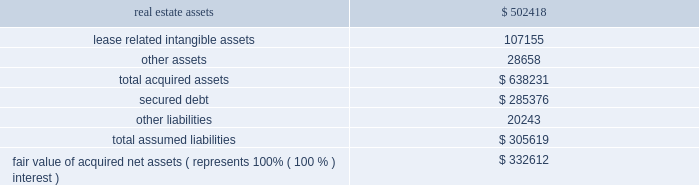57 annual report 2010 duke realty corporation | | level 2 inputs are inputs other than quoted prices included in level 1 that are observable for the asset or liability , either directly or indirectly .
Level 2 inputs may include quoted prices for similar assets and liabilities in active markets , as well as inputs that are observable for the asset or liability ( other than quoted prices ) , such as interest rates and yield curves that are observable at commonly quoted intervals .
Level 3 inputs are unobservable inputs for the asset or liability , which are typically based on an entity 2019s own assumptions , as there is little , if any , related market activity .
In instances where the determination of the fair value measurement is based on inputs from different levels of the fair value hierarchy , the level in the fair value hierarchy within which the entire fair value measurement falls is based on the lowest level input that is significant to the fair value measurement in its entirety .
Our assessment of the significance of a particular input to the fair value measurement in its entirety requires judgment and considers factors specific to the asset or liability .
Use of estimates the preparation of the financial statements requires management to make a number of estimates and assumptions that affect the reported amount of assets and liabilities and the disclosure of contingent assets and liabilities at the date of the financial statements and the reported amounts of revenues and expenses during the period .
The most significant estimates , as discussed within our summary of significant accounting policies , pertain to the critical assumptions utilized in testing real estate assets for impairment as well as in estimating the fair value of real estate assets when an impairment event has taken place .
Actual results could differ from those estimates .
( 3 ) significant acquisitions and dispositions 2010 acquisition of remaining interest in dugan realty , l.l.c .
On july 1 , 2010 , we acquired our joint venture partner 2019s 50% ( 50 % ) interest in dugan realty , l.l.c .
( 201cdugan 201d ) , a real estate joint venture that we had previously accounted for using the equity method , for a payment of $ 166.7 million .
Dugan held $ 28.1 million of cash at the time of acquisition , which resulted in a net cash outlay of $ 138.6 million .
As the result of this transaction we obtained 100% ( 100 % ) of dugan 2019s membership interests .
At the date of acquisition , dugan owned 106 industrial buildings totaling 20.8 million square feet and 63 net acres of undeveloped land located in midwest and southeast markets .
Dugan had a secured loan with a face value of $ 195.4 million due in october 2010 , which was repaid at its scheduled maturity date , and a secured loan with a face value of $ 87.6 million due in october 2012 ( see note 8 ) .
The acquisition was completed in order to pursue our strategy to increase our overall allocation to industrial real estate assets .
The table summarizes our allocation of the fair value of amounts recognized for each major class of assets and liabilities ( in thousands ) : .
Fair value of acquired net assets ( represents 100% ( 100 % ) interest ) $ 332612 we previously managed and performed other ancillary services for dugan 2019s properties and , as a result , dugan had no employees of its own and no .
What was the debt to equity ratio in the assets acquired? 
Computations: (305619 / 332612)
Answer: 0.91885. 